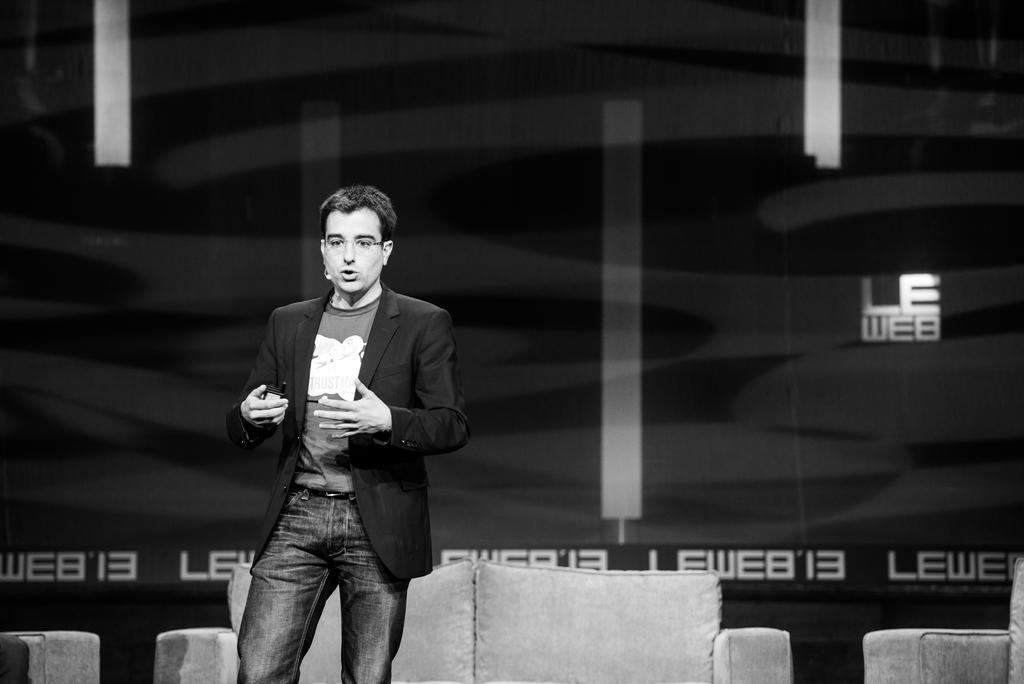Can you describe this image briefly? In this image there is a sofa on the left and on the right corner. There is a person standing in the foreground. There is a sofa, it looks like a banner in the background. 